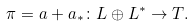Convert formula to latex. <formula><loc_0><loc_0><loc_500><loc_500>\pi = a + a _ { * } \colon L \oplus L ^ { * } \rightarrow T .</formula> 